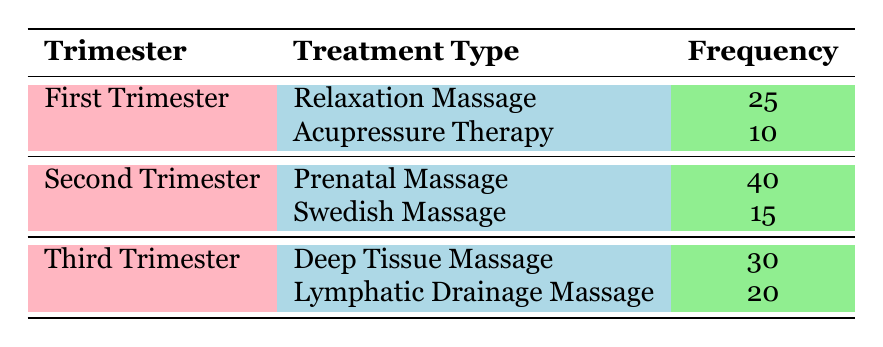What is the treatment type with the highest frequency request in the Second Trimester? In the table, the Second Trimester lists two treatment types: Prenatal Massage (40 requests) and Swedish Massage (15 requests). The highest frequency request is for Prenatal Massage.
Answer: Prenatal Massage How many total requests were made for massage treatments in the Third Trimester? There are two massage treatments listed for the Third Trimester: Deep Tissue Massage (30 requests) and Lymphatic Drainage Massage (20 requests). Adding them gives a total of 30 + 20 = 50 requests.
Answer: 50 Is Acupressure Therapy requested more often than Swedish Massage? Acupressure Therapy has 10 requests, while Swedish Massage has 15 requests. Since 10 is less than 15, Acupressure Therapy is requested less often.
Answer: No What is the average frequency of massage treatments requested in the First Trimester? There are two treatments in the First Trimester: Relaxation Massage (25 requests) and Acupressure Therapy (10 requests). The average is calculated as (25 + 10) / 2 = 17.5.
Answer: 17.5 Which trimester had the least requests for massage treatments overall? First Trimester had 25 (Relaxation Massage) + 10 (Acupressure Therapy) = 35 requests; Second Trimester had 40 (Prenatal Massage) + 15 (Swedish Massage) = 55 requests; Third Trimester had 30 (Deep Tissue Massage) + 20 (Lymphatic Drainage Massage) = 50 requests. The least is the First Trimester with 35 requests.
Answer: First Trimester What is the difference in frequency requests between the highest and lowest requested treatment types in the table? The highest requested treatment is Prenatal Massage with 40 requests, and the lowest is Acupressure Therapy with 10 requests. The difference is 40 - 10 = 30.
Answer: 30 